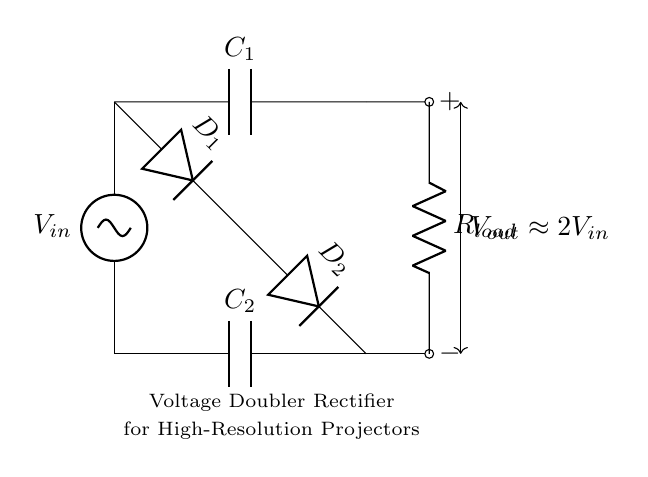What is the input voltage source labeled as? The input voltage source in the diagram is labeled as V_in, indicating it is the source voltage entering the rectifier circuit.
Answer: V_in How many diodes are present in this circuit? The diagram shows two diodes, D_1 and D_2, which are critical for the rectification process.
Answer: 2 What do the capacitors in this circuit do? The capacitors, labeled C_1 and C_2, serve to store charge, helping to smooth the output voltage and contribute to the voltage doubling effect.
Answer: Store charge What is the expected output voltage of this circuit? The diagram indicates that the expected output voltage, V_out, is approximately twice the input voltage, V_in. This is reflected in the label on the output line.
Answer: Approximately 2V_in What role does the load resistor play in this circuit? The load resistor, R_load, represents the component that consumes power and operates on the output voltage provided by the rectifier circuit.
Answer: Consumes power Why are two capacitors used instead of one? Two capacitors are used to allow the circuit to achieve a voltage doubler effect; each capacitor alternately charges and discharges, effectively raising the overall voltage output.
Answer: Voltage doubler effect What type of rectifier circuit is shown here? The circuit blocks current in one direction and allows it in the other while doubling the output voltage, defining it as a voltage doubler rectifier.
Answer: Voltage doubler rectifier 